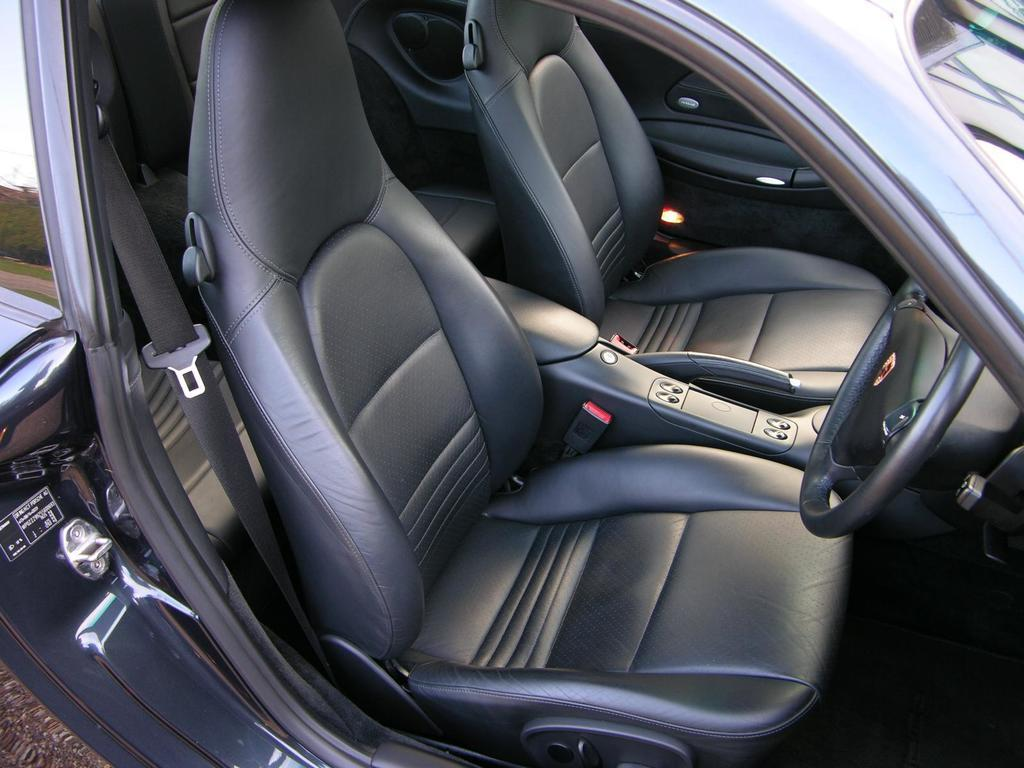What is the main subject of the image? The main subject of the image is a vehicle. What features does the vehicle have? The vehicle has seats and a steering wheel. How many nuts are stored in the vehicle in the image? There is no mention of nuts in the image, so it is impossible to determine how many might be present. 